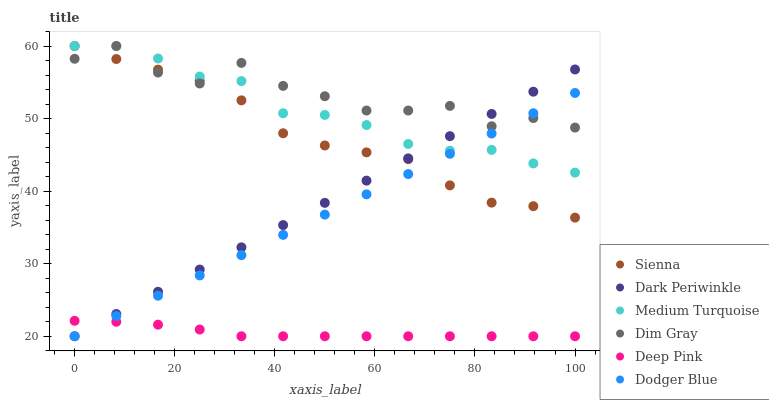Does Deep Pink have the minimum area under the curve?
Answer yes or no. Yes. Does Dim Gray have the maximum area under the curve?
Answer yes or no. Yes. Does Sienna have the minimum area under the curve?
Answer yes or no. No. Does Sienna have the maximum area under the curve?
Answer yes or no. No. Is Dark Periwinkle the smoothest?
Answer yes or no. Yes. Is Dim Gray the roughest?
Answer yes or no. Yes. Is Sienna the smoothest?
Answer yes or no. No. Is Sienna the roughest?
Answer yes or no. No. Does Deep Pink have the lowest value?
Answer yes or no. Yes. Does Sienna have the lowest value?
Answer yes or no. No. Does Medium Turquoise have the highest value?
Answer yes or no. Yes. Does Deep Pink have the highest value?
Answer yes or no. No. Is Deep Pink less than Medium Turquoise?
Answer yes or no. Yes. Is Medium Turquoise greater than Deep Pink?
Answer yes or no. Yes. Does Dodger Blue intersect Dim Gray?
Answer yes or no. Yes. Is Dodger Blue less than Dim Gray?
Answer yes or no. No. Is Dodger Blue greater than Dim Gray?
Answer yes or no. No. Does Deep Pink intersect Medium Turquoise?
Answer yes or no. No. 